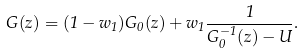<formula> <loc_0><loc_0><loc_500><loc_500>G ( z ) = ( 1 - w _ { 1 } ) G _ { 0 } ( z ) + w _ { 1 } \frac { 1 } { G _ { 0 } ^ { - 1 } ( z ) - U } .</formula> 